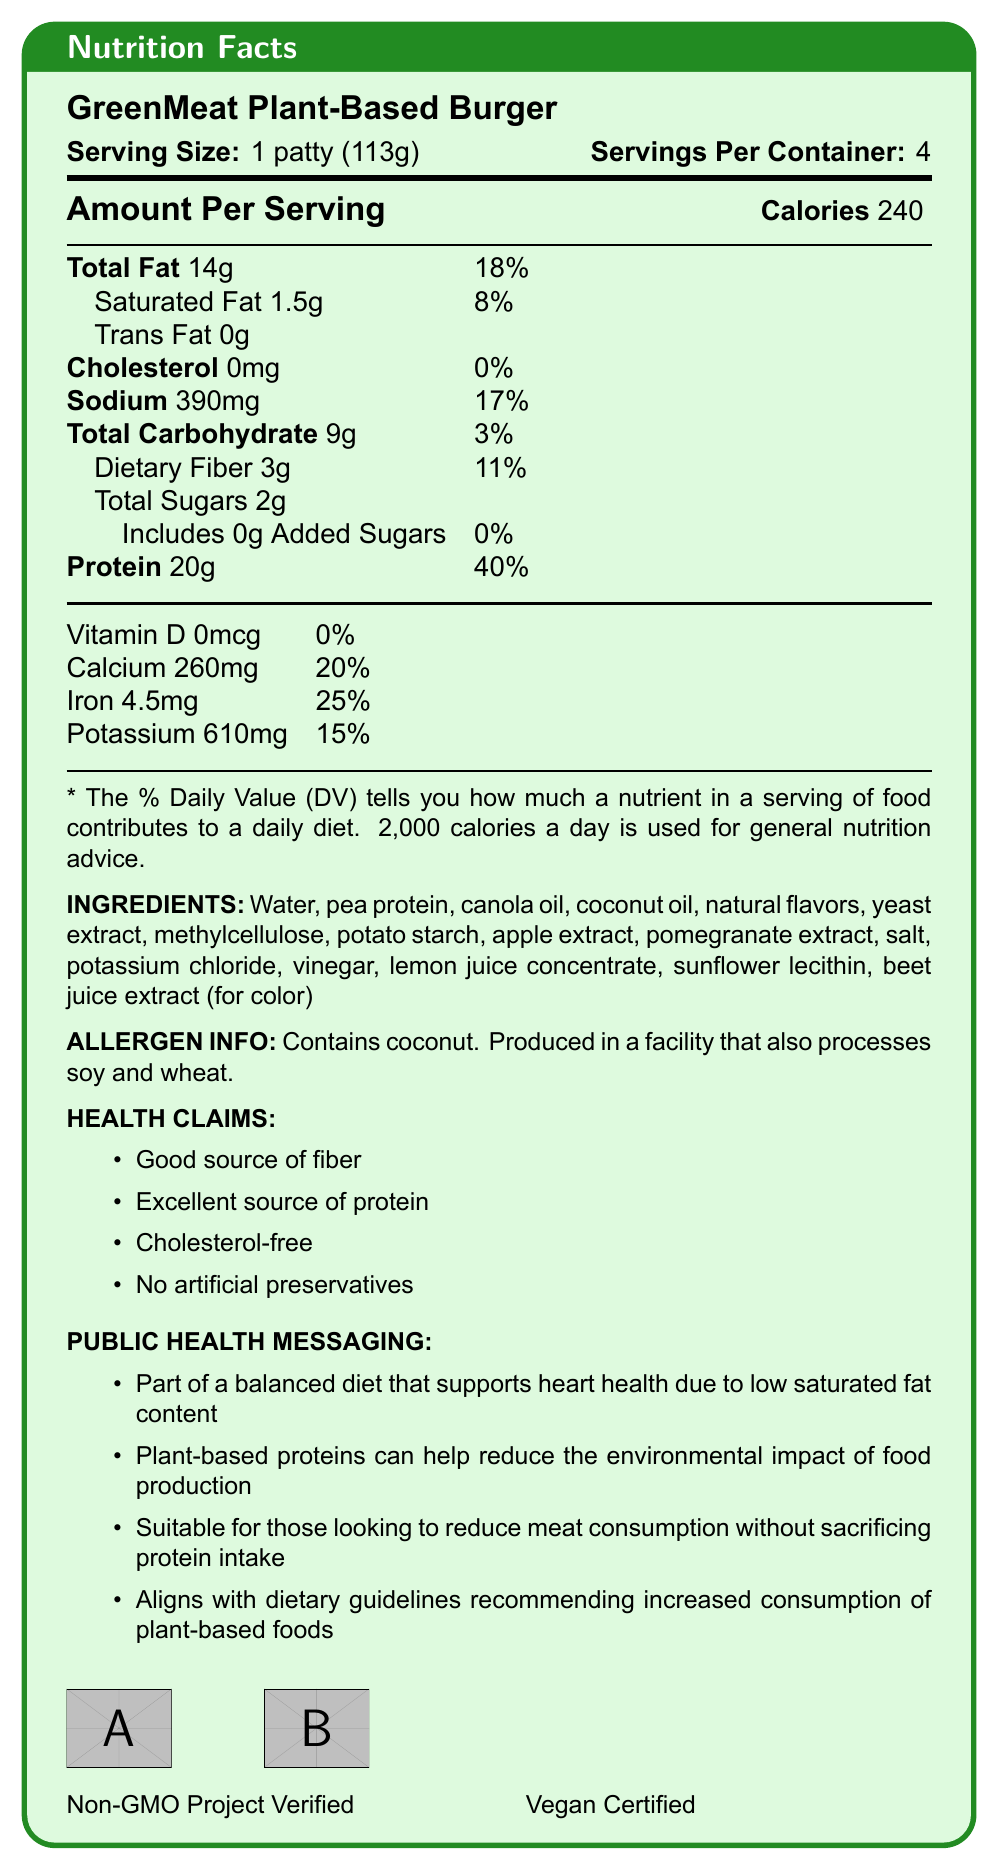what is the serving size of the GreenMeat Plant-Based Burger? The document specifies that the serving size is 1 patty (113g).
Answer: 1 patty (113g) how many grams of protein are in one serving of the GreenMeat Plant-Based Burger? The nutrition facts state that there are 20g of protein per serving.
Answer: 20g what percentage of the daily value for saturated fat does one serving of the GreenMeat Plant-Based Burger provide? The document shows that one serving contains 1.5g of saturated fat, which is 8% of the daily value.
Answer: 8% what type of allergen is contained in the GreenMeat Plant-Based Burger? The allergen information specifies that the product contains coconut.
Answer: Coconut how many servings are there per container? The document states that there are 4 servings per container.
Answer: 4 does the GreenMeat Plant-Based Burger contain any cholesterol? (yes/no) The nutrition facts label shows 0mg of cholesterol in the product.
Answer: No which of the following is not listed as a health claim for the GreenMeat Plant-Based Burger? A. Good source of fiber B. Low in sodium C. Excellent source of protein D. Cholesterol-free The listed health claims include "Good source of fiber," "Excellent source of protein," and "Cholesterol-free" but not "Low in sodium."
Answer: B what are two certifications shown on the GreenMeat Plant-Based Burger packaging? The document includes logos for Non-GMO Project Verified and Vegan Certified.
Answer: Non-GMO Project Verified and Vegan Certified List three ingredients found in the GreenMeat Plant-Based Burger. The ingredients list includes water, pea protein, and canola oil, among other ingredients.
Answer: Water, pea protein, canola oil what is the purpose of the beet juice extract in the GreenMeat Plant-Based Burger according to the ingredient list? The document states that beet juice extract is used for color.
Answer: For color summarize the main idea of the GreenMeat Plant-Based Burger Nutrition Facts Label. This summary encapsulates the key nutritional content, ingredients, health claims, and public health messages provided in the document.
Answer: The GreenMeat Plant-Based Burger is a plant-based meat alternative highlighting its high protein content (20g per serving) and low saturated fat (1.5g per serving). It is cholesterol-free, contains 14g of total fat, and includes a variety of vitamins and minerals. The burger is made from ingredients like pea protein and various natural extracts and is certified both Non-GMO and Vegan. It is promoted as being part of a balanced diet supporting heart health, environmentally friendly, and suitable for those reducing meat consumption. how many grams of dietary fiber does one serving of the GreenMeat Plant-Based Burger contain? The nutrition facts specify that there are 3g of dietary fiber per serving.
Answer: 3g is the GreenMeat Plant-Based Burger considered a good source of fiber? (yes/no) The health claims section of the document indicates that the burger is a good source of fiber.
Answer: Yes based on the document, is the GreenMeat Plant-Based Burger suitable for individuals with soy allergies? While the product is produced in a facility that processes soy, the document does not explicitly state whether the product itself contains soy.
Answer: Not enough information do GreenMeat Plant-Based Burgers contain artificial preservatives? (yes/no) The health claims section specifies that the product contains no artificial preservatives.
Answer: No what is the daily value percentage of iron provided by one serving of the GreenMeat Plant-Based Burger? The nutrition facts state that one serving provides 25% of the daily value for iron.
Answer: 25% 